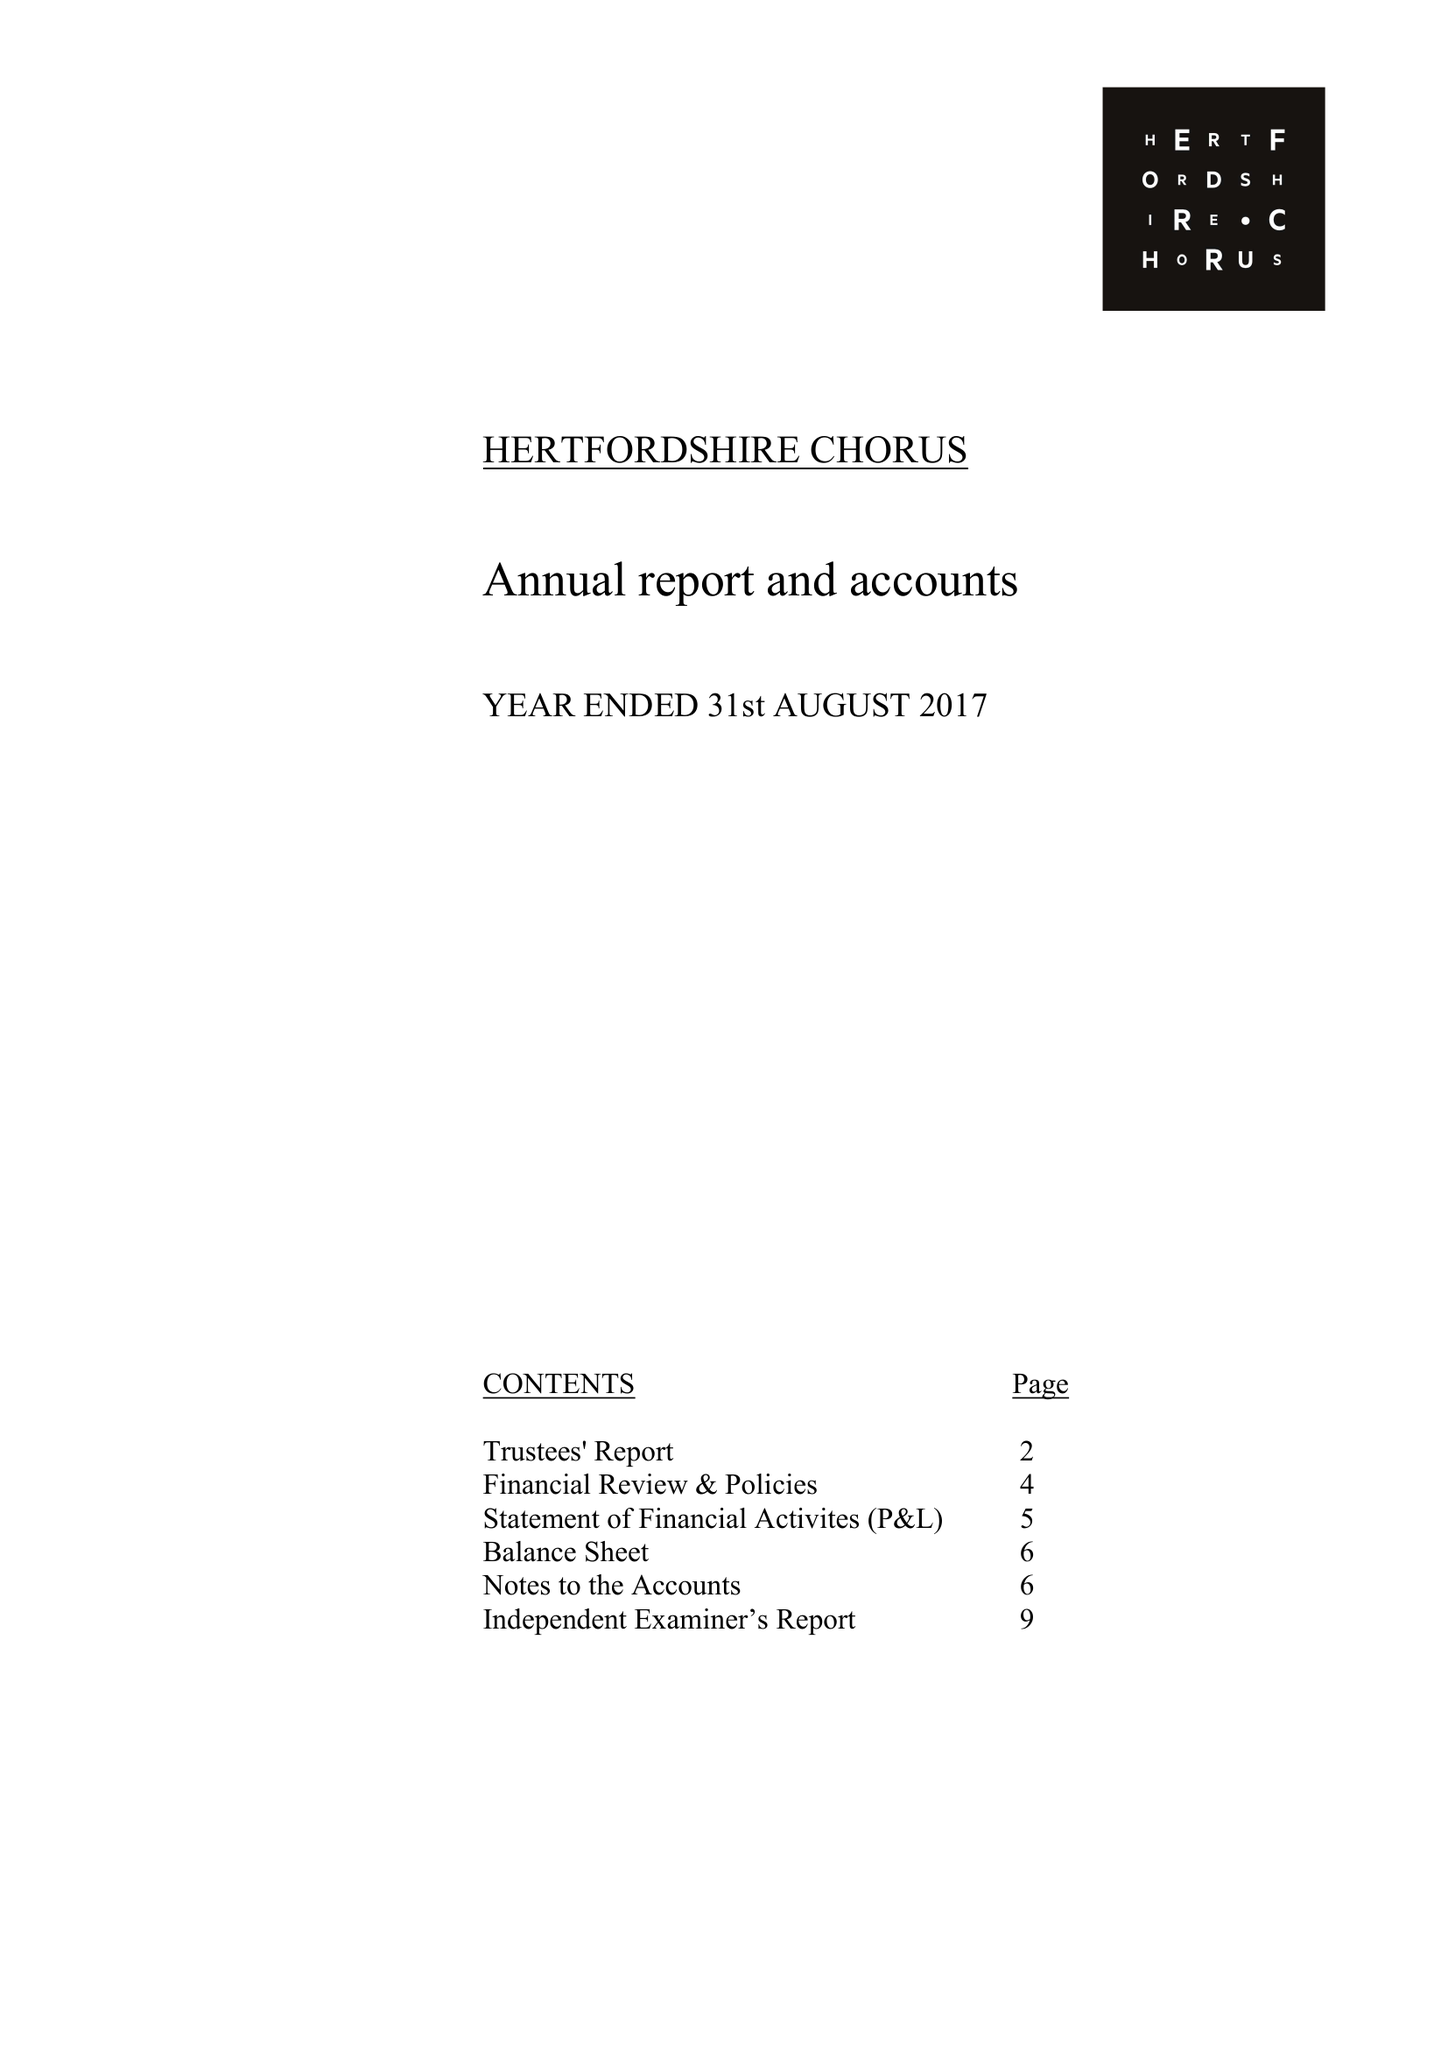What is the value for the report_date?
Answer the question using a single word or phrase. 2017-08-31 